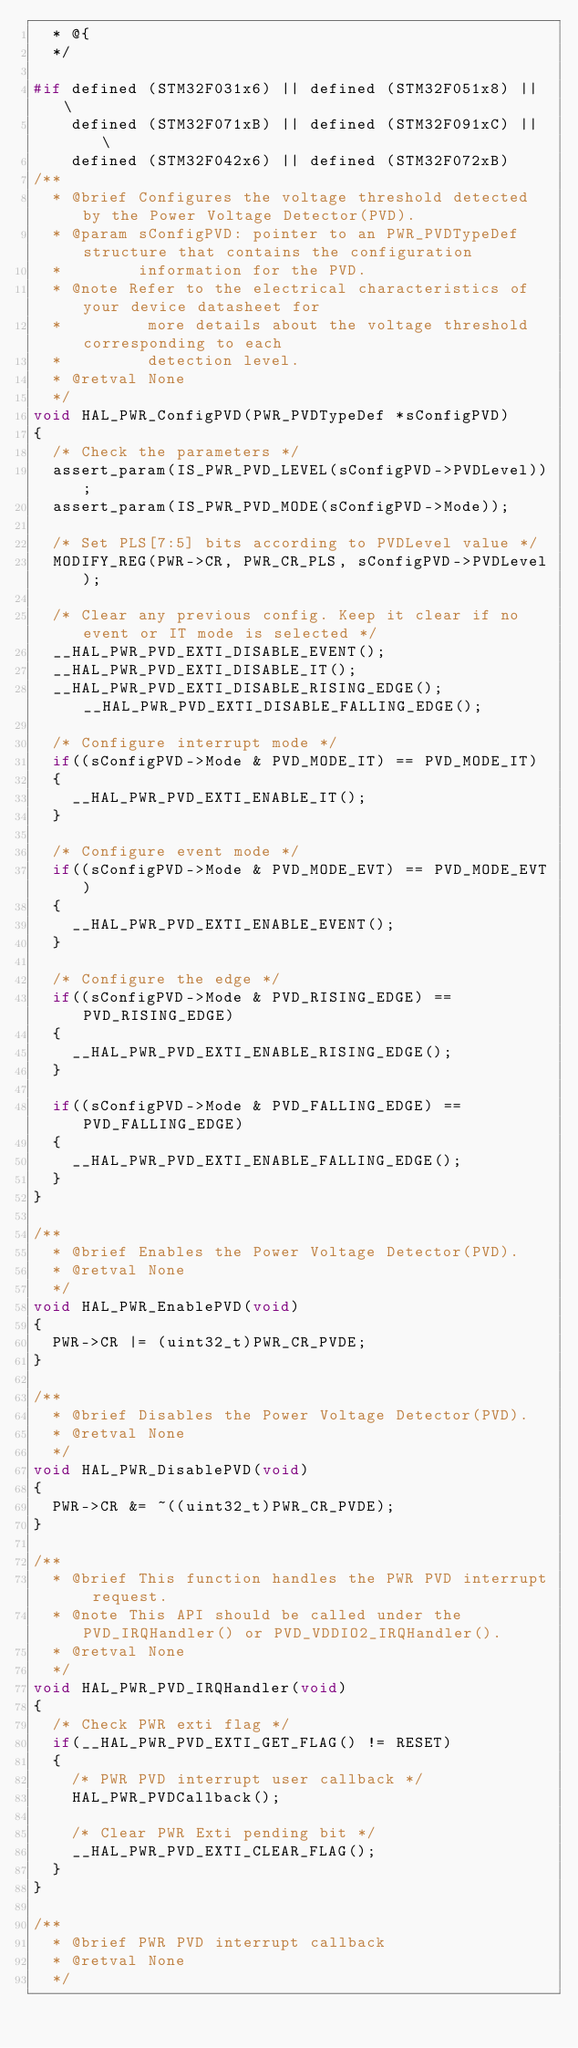Convert code to text. <code><loc_0><loc_0><loc_500><loc_500><_C_>  * @{
  */

#if defined (STM32F031x6) || defined (STM32F051x8) || \
    defined (STM32F071xB) || defined (STM32F091xC) || \
    defined (STM32F042x6) || defined (STM32F072xB)
/**
  * @brief Configures the voltage threshold detected by the Power Voltage Detector(PVD).
  * @param sConfigPVD: pointer to an PWR_PVDTypeDef structure that contains the configuration
  *        information for the PVD.
  * @note Refer to the electrical characteristics of your device datasheet for
  *         more details about the voltage threshold corresponding to each
  *         detection level.
  * @retval None
  */
void HAL_PWR_ConfigPVD(PWR_PVDTypeDef *sConfigPVD)
{
  /* Check the parameters */
  assert_param(IS_PWR_PVD_LEVEL(sConfigPVD->PVDLevel));
  assert_param(IS_PWR_PVD_MODE(sConfigPVD->Mode));

  /* Set PLS[7:5] bits according to PVDLevel value */
  MODIFY_REG(PWR->CR, PWR_CR_PLS, sConfigPVD->PVDLevel);
  
  /* Clear any previous config. Keep it clear if no event or IT mode is selected */
  __HAL_PWR_PVD_EXTI_DISABLE_EVENT();
  __HAL_PWR_PVD_EXTI_DISABLE_IT();
  __HAL_PWR_PVD_EXTI_DISABLE_RISING_EDGE();__HAL_PWR_PVD_EXTI_DISABLE_FALLING_EDGE();

  /* Configure interrupt mode */
  if((sConfigPVD->Mode & PVD_MODE_IT) == PVD_MODE_IT)
  {
    __HAL_PWR_PVD_EXTI_ENABLE_IT();
  }
  
  /* Configure event mode */
  if((sConfigPVD->Mode & PVD_MODE_EVT) == PVD_MODE_EVT)
  {
    __HAL_PWR_PVD_EXTI_ENABLE_EVENT();
  }
  
  /* Configure the edge */
  if((sConfigPVD->Mode & PVD_RISING_EDGE) == PVD_RISING_EDGE)
  {
    __HAL_PWR_PVD_EXTI_ENABLE_RISING_EDGE();
  }
  
  if((sConfigPVD->Mode & PVD_FALLING_EDGE) == PVD_FALLING_EDGE)
  {
    __HAL_PWR_PVD_EXTI_ENABLE_FALLING_EDGE();
  }
}

/**
  * @brief Enables the Power Voltage Detector(PVD).
  * @retval None
  */
void HAL_PWR_EnablePVD(void)
{
  PWR->CR |= (uint32_t)PWR_CR_PVDE;
}

/**
  * @brief Disables the Power Voltage Detector(PVD).
  * @retval None
  */
void HAL_PWR_DisablePVD(void)
{
  PWR->CR &= ~((uint32_t)PWR_CR_PVDE);
}

/**
  * @brief This function handles the PWR PVD interrupt request.
  * @note This API should be called under the  PVD_IRQHandler() or PVD_VDDIO2_IRQHandler().
  * @retval None
  */
void HAL_PWR_PVD_IRQHandler(void)
{
  /* Check PWR exti flag */
  if(__HAL_PWR_PVD_EXTI_GET_FLAG() != RESET)
  {
    /* PWR PVD interrupt user callback */
    HAL_PWR_PVDCallback();

    /* Clear PWR Exti pending bit */
    __HAL_PWR_PVD_EXTI_CLEAR_FLAG();
  }
}

/**
  * @brief PWR PVD interrupt callback
  * @retval None
  */</code> 